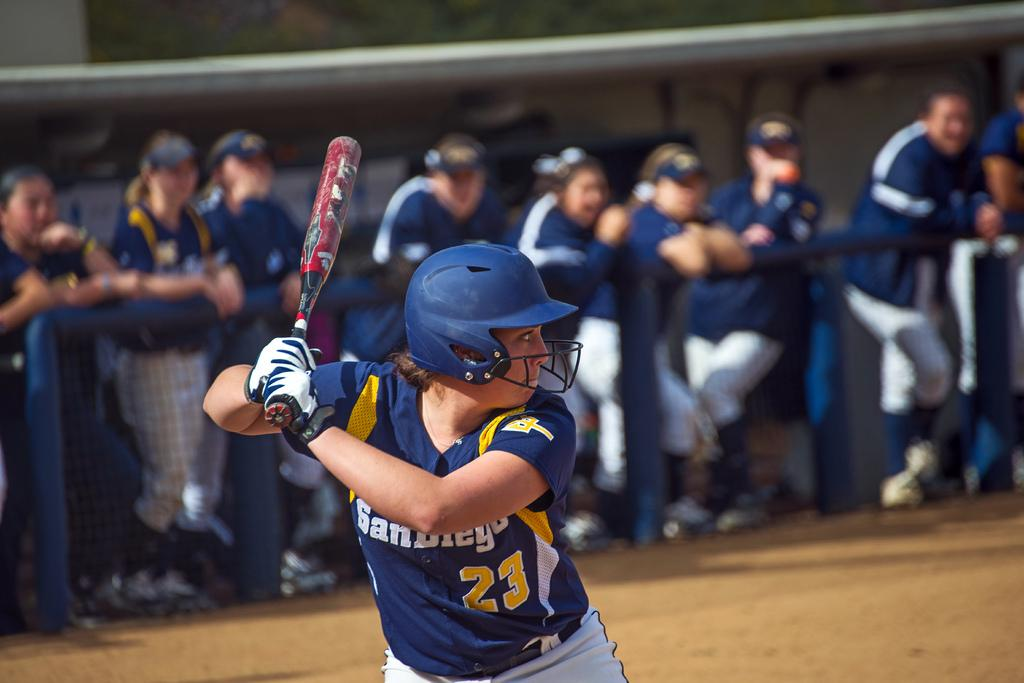Provide a one-sentence caption for the provided image. a boy in San Diego jersey number 23 up to bat. 